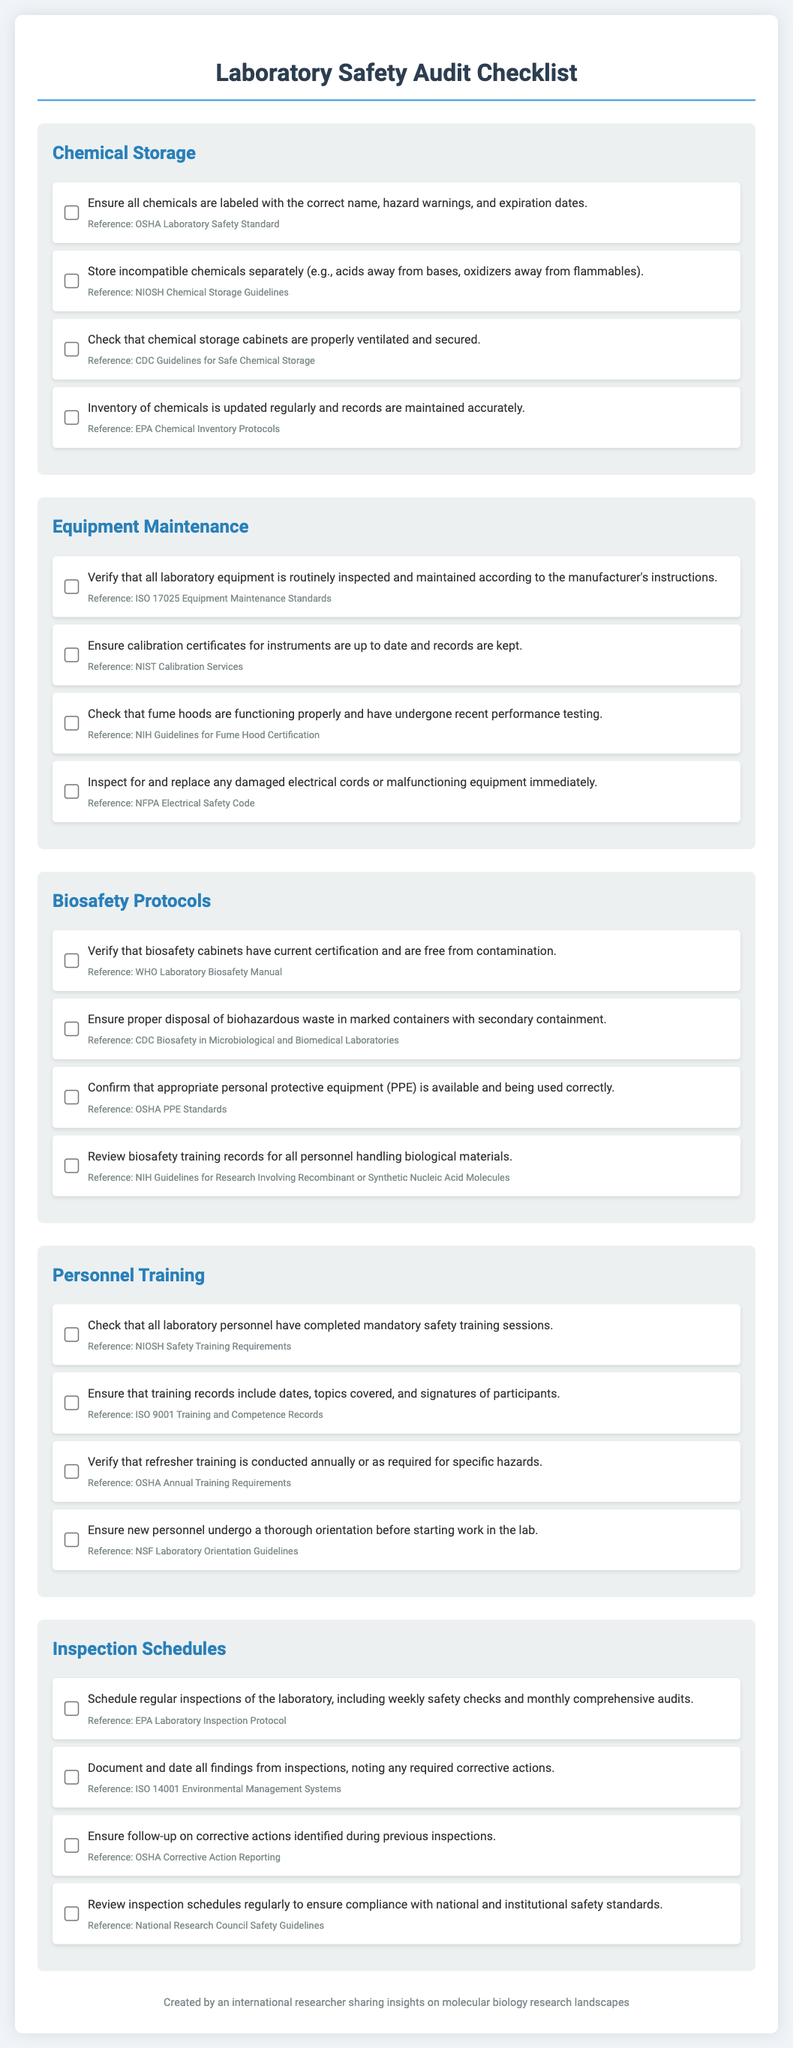what is the title of the document? The title of the document is presented at the top of the rendered checklist.
Answer: Laboratory Safety Audit Checklist how many sections are in the checklist? The checklist has five distinct sections covering various aspects of laboratory safety.
Answer: 5 what should be done to ensure proper chemical storage? The checklist specifies actions that must be taken to comply with safety standards regarding chemical storage.
Answer: Ensure all chemicals are labeled with the correct name, hazard warnings, and expiration dates which equipment requires routine inspection and maintenance? The document outlines the necessity for maintaining laboratory equipment in accordance with the manufacturer's instructions.
Answer: All laboratory equipment what is the reference for ensuring proper disposal of biohazardous waste? The document includes references for each requirement, including safety waste disposal practices.
Answer: CDC Biosafety in Microbiological and Biomedical Laboratories how often should refresher training be conducted? The checklist details the requirements for personnel training, including frequency of training sessions.
Answer: Annually what is the recommended follow-up action for previous inspection findings? The checklist outlines compliance steps that should be taken following inspections.
Answer: Ensure follow-up on corrective actions identified during previous inspections who established the equipment maintenance standards referenced in the checklist? The source of the equipment maintenance guidance is provided in the document.
Answer: ISO 17025 Equipment Maintenance Standards 